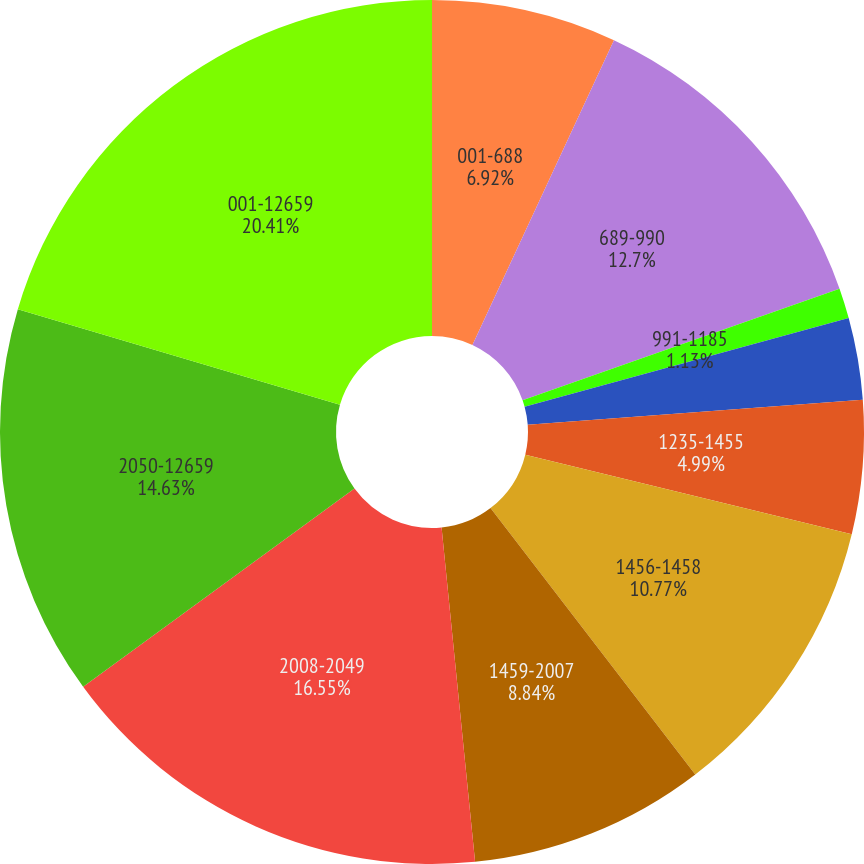Convert chart. <chart><loc_0><loc_0><loc_500><loc_500><pie_chart><fcel>001-688<fcel>689-990<fcel>991-1185<fcel>1186-1234<fcel>1235-1455<fcel>1456-1458<fcel>1459-2007<fcel>2008-2049<fcel>2050-12659<fcel>001-12659<nl><fcel>6.92%<fcel>12.7%<fcel>1.13%<fcel>3.06%<fcel>4.99%<fcel>10.77%<fcel>8.84%<fcel>16.55%<fcel>14.63%<fcel>20.41%<nl></chart> 